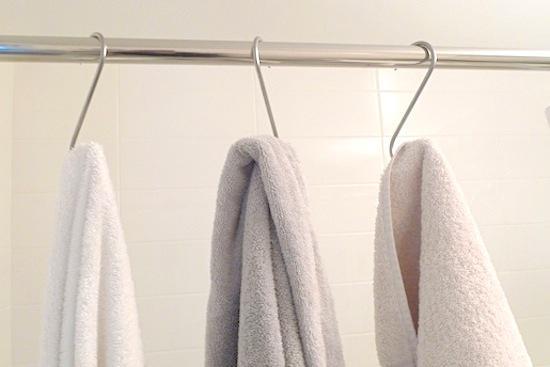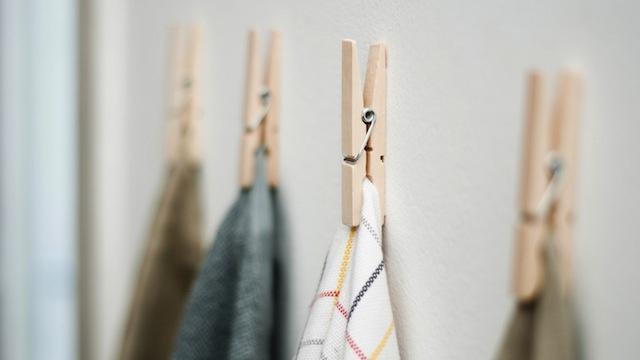The first image is the image on the left, the second image is the image on the right. For the images shown, is this caption "There are two hanging towels in the left image." true? Answer yes or no. No. The first image is the image on the left, the second image is the image on the right. For the images shown, is this caption "In one of the images, the towels are hung on something mounted to a wooden board along the wall." true? Answer yes or no. No. 